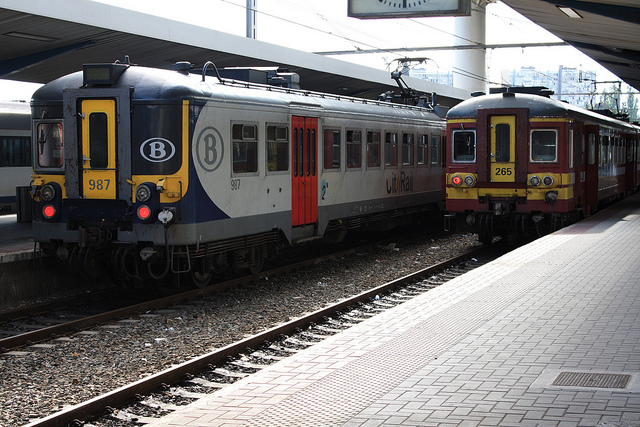Can you describe the design or model of the trains in the image? Both trains have a classic design, likely to be commuter trains given their build and design. They feature multiple cars with distinct, small windows and are equipped with overhead electrical lines, indicative of electric propulsion. 